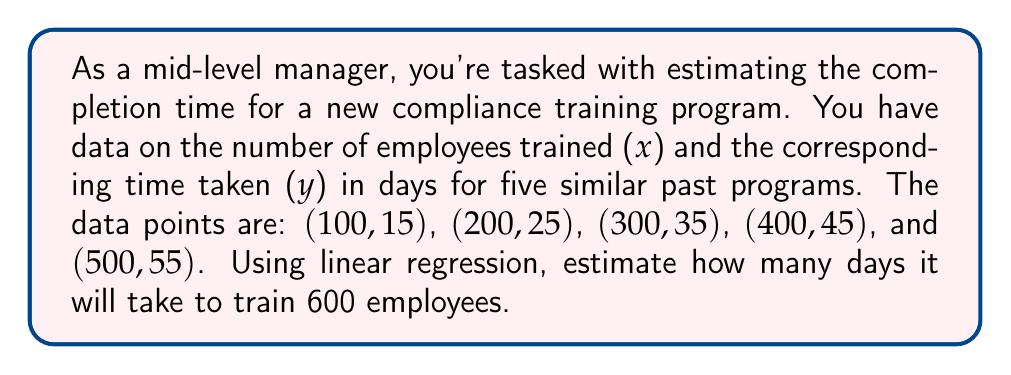Teach me how to tackle this problem. To solve this problem using linear regression, we'll follow these steps:

1. Calculate the means of x and y:
   $\bar{x} = \frac{100 + 200 + 300 + 400 + 500}{5} = 300$
   $\bar{y} = \frac{15 + 25 + 35 + 45 + 55}{5} = 35$

2. Calculate the slope (m) using the formula:
   $m = \frac{\sum{(x_i - \bar{x})(y_i - \bar{y})}}{\sum{(x_i - \bar{x})^2}}$

   $\sum{(x_i - \bar{x})(y_i - \bar{y})} = (-200)(-20) + (-100)(-10) + (0)(0) + (100)(10) + (200)(20) = 10000$
   $\sum{(x_i - \bar{x})^2} = (-200)^2 + (-100)^2 + (0)^2 + (100)^2 + (200)^2 = 100000$

   $m = \frac{10000}{100000} = 0.1$

3. Calculate the y-intercept (b) using the formula:
   $b = \bar{y} - m\bar{x}$
   $b = 35 - (0.1)(300) = 5$

4. The linear regression equation is:
   $y = mx + b = 0.1x + 5$

5. To estimate the time for 600 employees, substitute x = 600:
   $y = 0.1(600) + 5 = 60 + 5 = 65$

Therefore, it is estimated to take 65 days to train 600 employees.
Answer: 65 days 